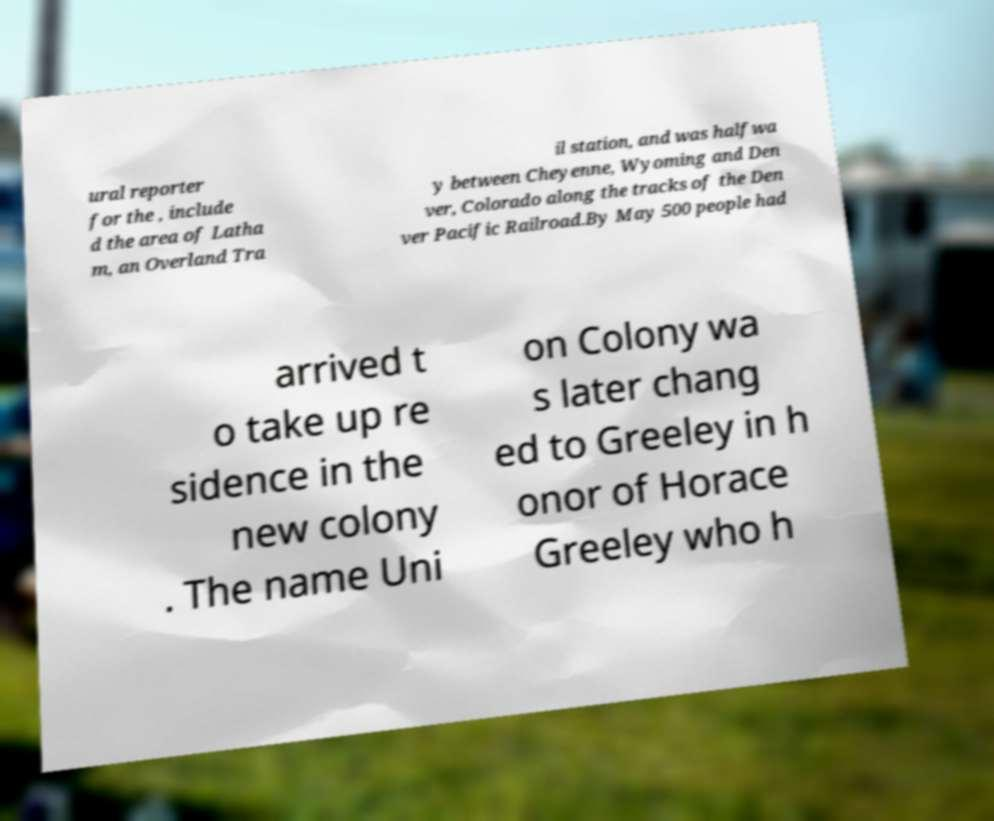I need the written content from this picture converted into text. Can you do that? ural reporter for the , include d the area of Latha m, an Overland Tra il station, and was halfwa y between Cheyenne, Wyoming and Den ver, Colorado along the tracks of the Den ver Pacific Railroad.By May 500 people had arrived t o take up re sidence in the new colony . The name Uni on Colony wa s later chang ed to Greeley in h onor of Horace Greeley who h 